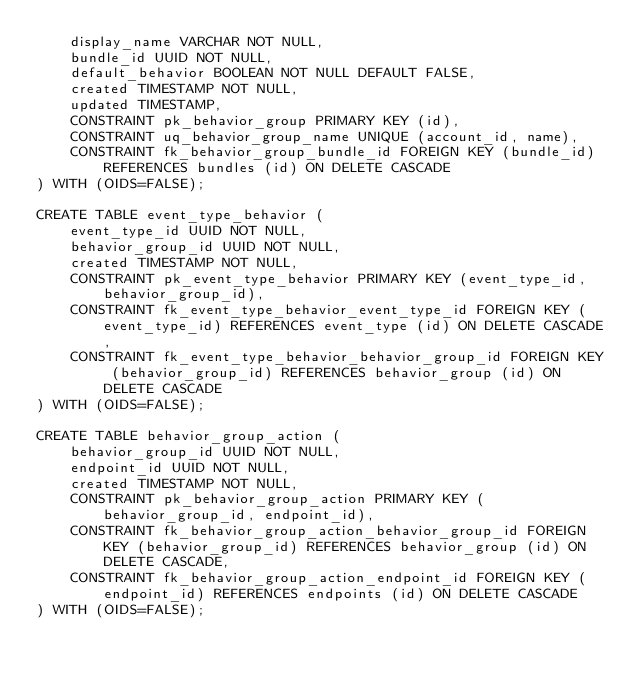Convert code to text. <code><loc_0><loc_0><loc_500><loc_500><_SQL_>    display_name VARCHAR NOT NULL,
    bundle_id UUID NOT NULL,
    default_behavior BOOLEAN NOT NULL DEFAULT FALSE,
    created TIMESTAMP NOT NULL,
    updated TIMESTAMP,
    CONSTRAINT pk_behavior_group PRIMARY KEY (id),
    CONSTRAINT uq_behavior_group_name UNIQUE (account_id, name),
    CONSTRAINT fk_behavior_group_bundle_id FOREIGN KEY (bundle_id) REFERENCES bundles (id) ON DELETE CASCADE
) WITH (OIDS=FALSE);

CREATE TABLE event_type_behavior (
    event_type_id UUID NOT NULL,
    behavior_group_id UUID NOT NULL,
    created TIMESTAMP NOT NULL,
    CONSTRAINT pk_event_type_behavior PRIMARY KEY (event_type_id, behavior_group_id),
    CONSTRAINT fk_event_type_behavior_event_type_id FOREIGN KEY (event_type_id) REFERENCES event_type (id) ON DELETE CASCADE,
    CONSTRAINT fk_event_type_behavior_behavior_group_id FOREIGN KEY (behavior_group_id) REFERENCES behavior_group (id) ON DELETE CASCADE
) WITH (OIDS=FALSE);

CREATE TABLE behavior_group_action (
    behavior_group_id UUID NOT NULL,
    endpoint_id UUID NOT NULL,
    created TIMESTAMP NOT NULL,
    CONSTRAINT pk_behavior_group_action PRIMARY KEY (behavior_group_id, endpoint_id),
    CONSTRAINT fk_behavior_group_action_behavior_group_id FOREIGN KEY (behavior_group_id) REFERENCES behavior_group (id) ON DELETE CASCADE,
    CONSTRAINT fk_behavior_group_action_endpoint_id FOREIGN KEY (endpoint_id) REFERENCES endpoints (id) ON DELETE CASCADE
) WITH (OIDS=FALSE);
</code> 